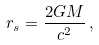Convert formula to latex. <formula><loc_0><loc_0><loc_500><loc_500>r _ { s } = \frac { 2 G M } { c ^ { 2 } } \, ,</formula> 